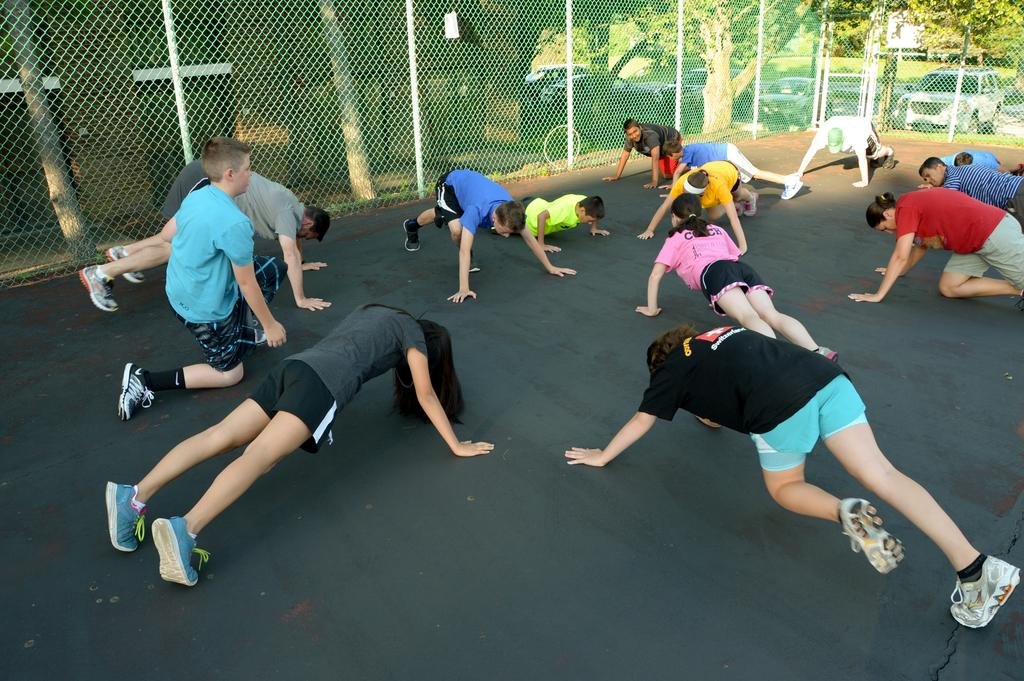What are the people in the image doing? There is a group of people on the floor in the image, which suggests they might be sitting or playing. What can be seen in the image besides the people? There is a fencing net, a building, grass, vehicles, and trees visible in the image. Can you describe the setting of the image? The image appears to be set outdoors, given the presence of grass, trees, and vehicles in the background. What type of print can be seen on the fencing net in the image? There is no print visible on the fencing net in the image; it appears to be a plain net. 